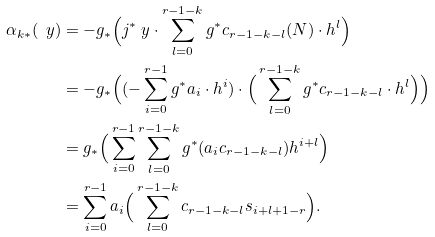Convert formula to latex. <formula><loc_0><loc_0><loc_500><loc_500>\alpha _ { k * } ( \ y ) & = - g _ { * } \Big { ( } j ^ { * } \ y \cdot \sum _ { l = 0 } ^ { r - 1 - k } g ^ { * } c _ { r - 1 - k - l } ( N ) \cdot h ^ { l } \Big { ) } \\ & = - g _ { * } \Big { ( } ( - \sum _ { i = 0 } ^ { r - 1 } g ^ { * } a _ { i } \cdot h ^ { i } ) \cdot \Big { ( } \sum _ { l = 0 } ^ { r - 1 - k } g ^ { * } c _ { r - 1 - k - l } \cdot h ^ { l } \Big { ) } \Big { ) } \\ & = g _ { * } \Big { ( } \sum _ { i = 0 } ^ { r - 1 } \sum _ { l = 0 } ^ { r - 1 - k } g ^ { * } ( a _ { i } c _ { r - 1 - k - l } ) h ^ { i + l } \Big { ) } \\ & = \sum _ { i = 0 } ^ { r - 1 } a _ { i } \Big { ( } \sum _ { l = 0 } ^ { r - 1 - k } c _ { r - 1 - k - l } s _ { i + l + 1 - r } \Big { ) } .</formula> 